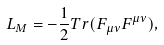<formula> <loc_0><loc_0><loc_500><loc_500>L _ { M } = - \frac { 1 } { 2 } T r ( F _ { \mu \nu } F ^ { \mu \nu } ) ,</formula> 